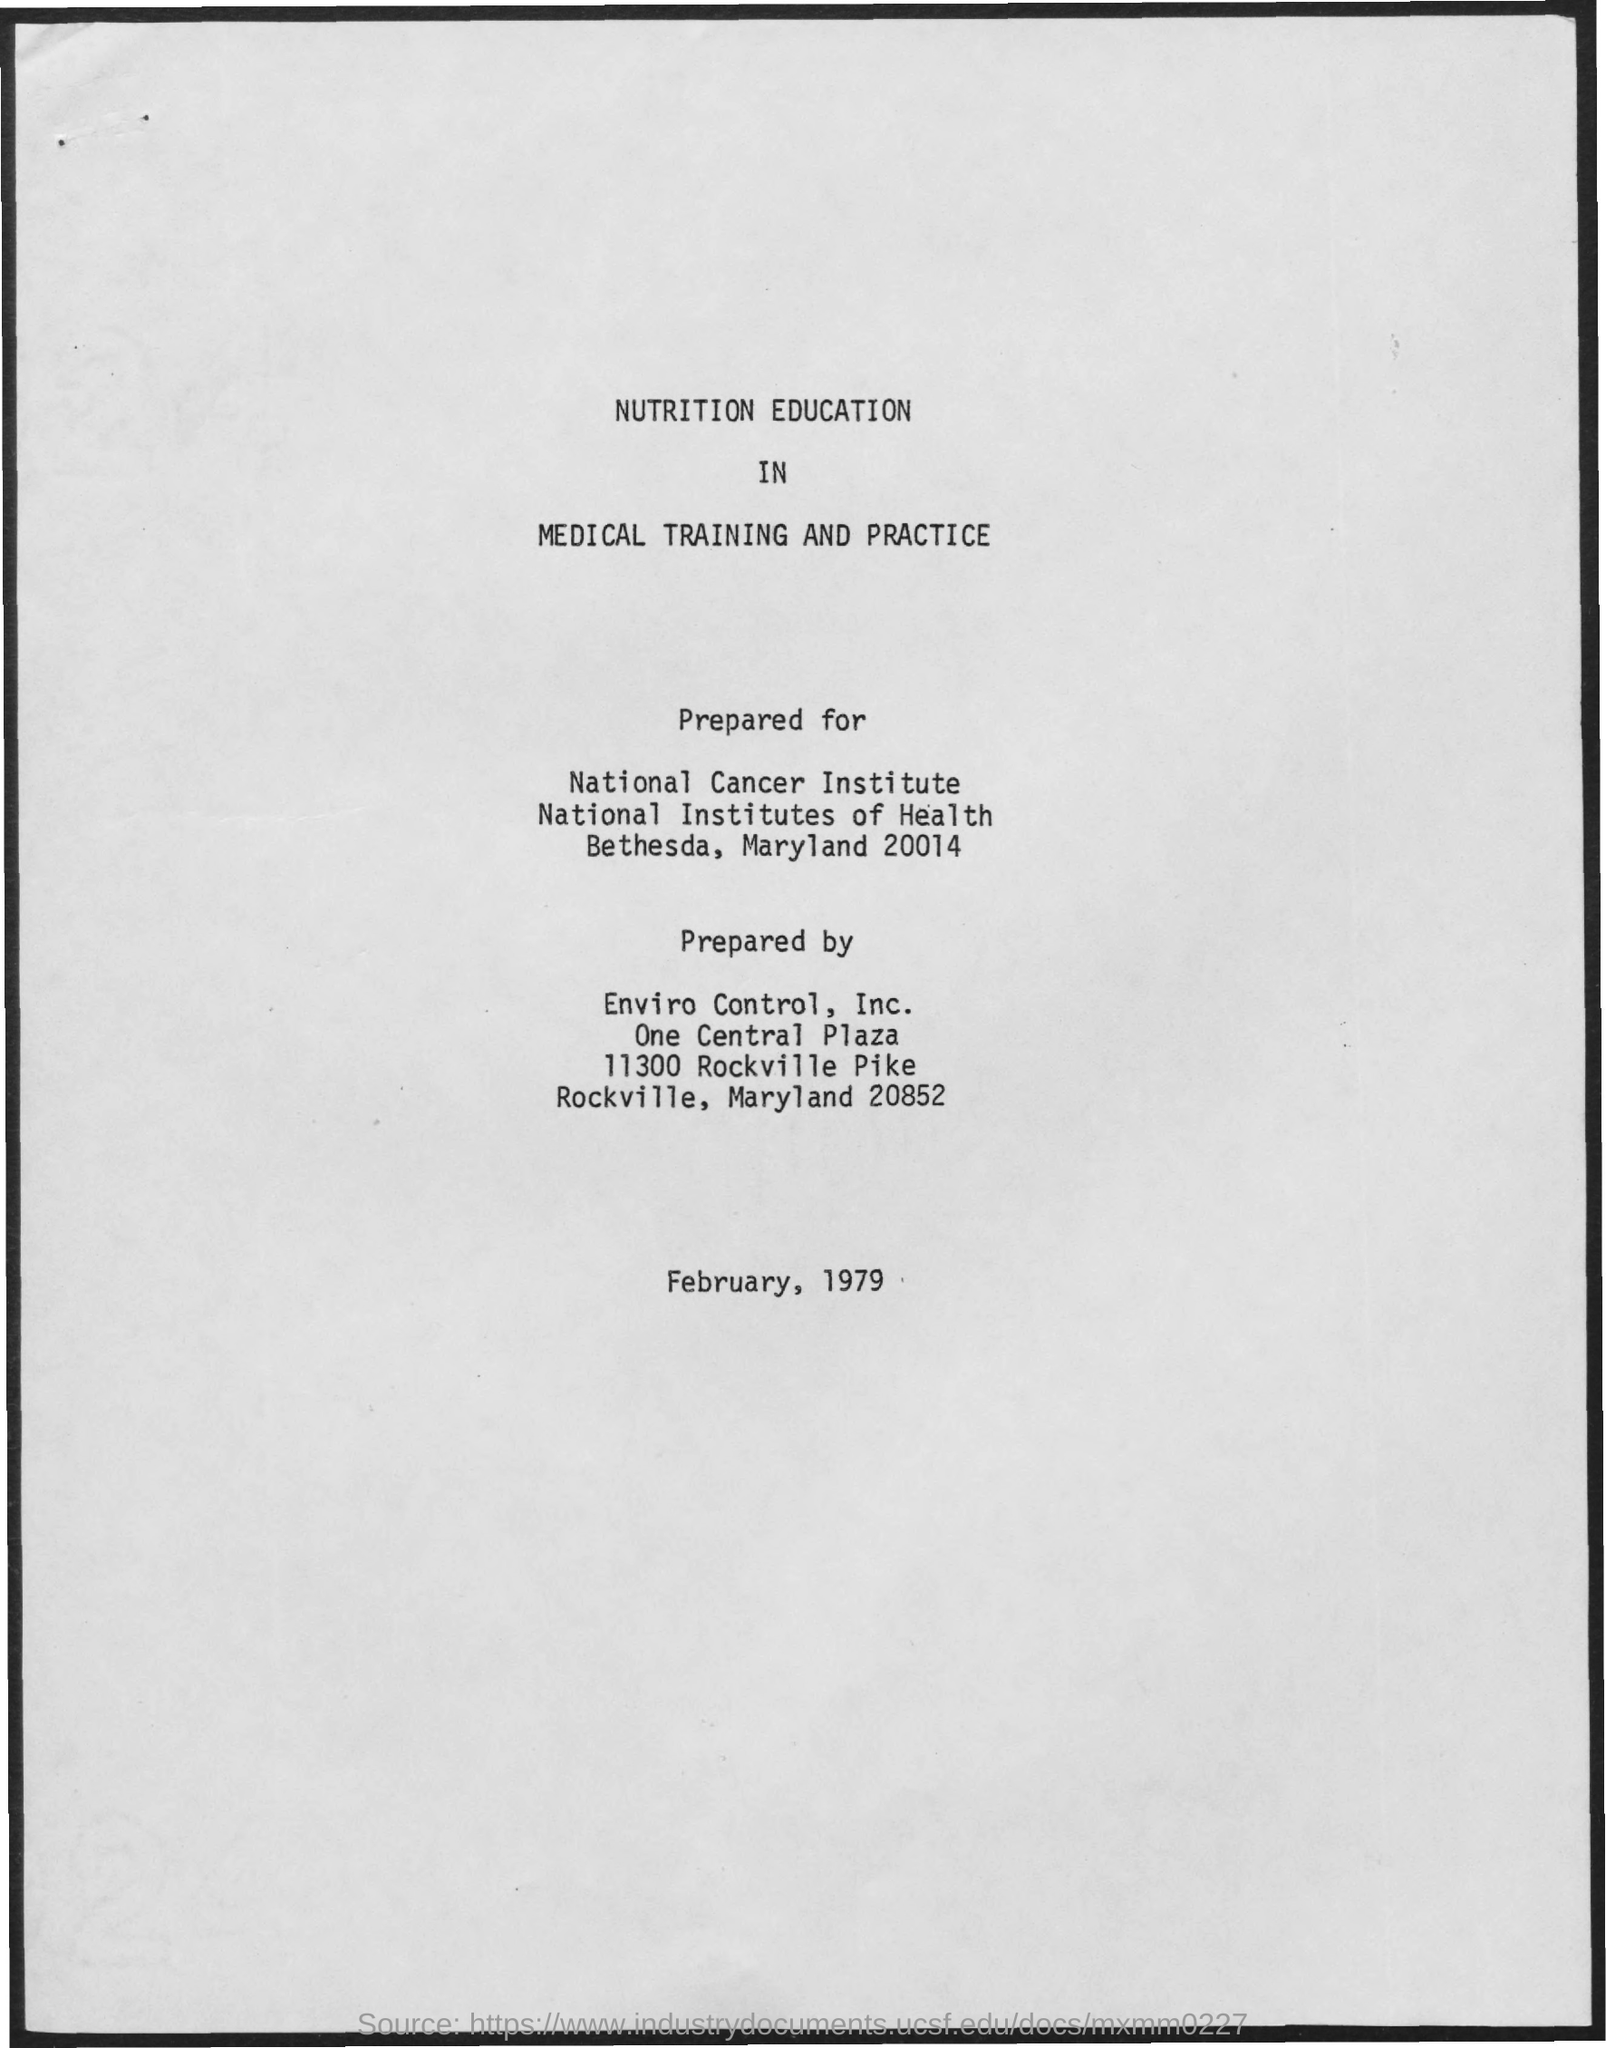What is the date on the document?
Offer a very short reply. February, 1979. Who is it prepared by?
Provide a succinct answer. Enviro Control, Inc. 